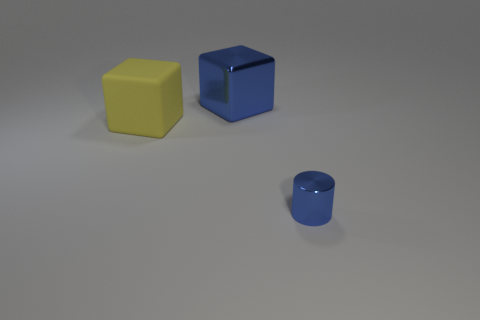Is there any other thing that has the same material as the big yellow block?
Make the answer very short. No. What is the material of the tiny blue thing?
Ensure brevity in your answer.  Metal. What number of yellow rubber things have the same shape as the large blue object?
Provide a short and direct response. 1. What is the material of the cube that is the same color as the small thing?
Your answer should be very brief. Metal. Is there anything else that is the same shape as the large blue metal thing?
Your answer should be compact. Yes. What is the color of the thing that is on the right side of the blue shiny object behind the blue metallic object that is in front of the matte thing?
Provide a succinct answer. Blue. How many small things are blue metal things or cyan metallic cubes?
Provide a succinct answer. 1. Are there the same number of large blue objects that are left of the large matte cube and big cyan metallic blocks?
Give a very brief answer. Yes. There is a metal cylinder; are there any tiny metallic cylinders to the right of it?
Your response must be concise. No. What number of metallic objects are big green cubes or small blue objects?
Make the answer very short. 1. 